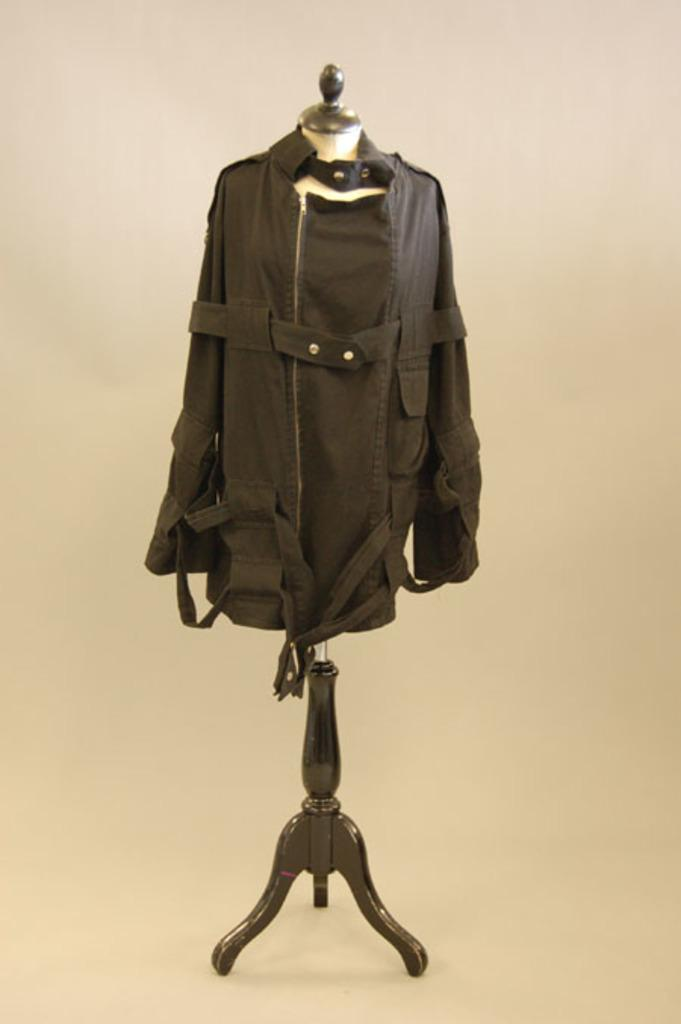What is hanging on the doll hanger in the image? There is a coat on a doll hanger in the image. Where is the zoo located in the image? There is no zoo present in the image; it features a coat hanging on a doll hanger. 